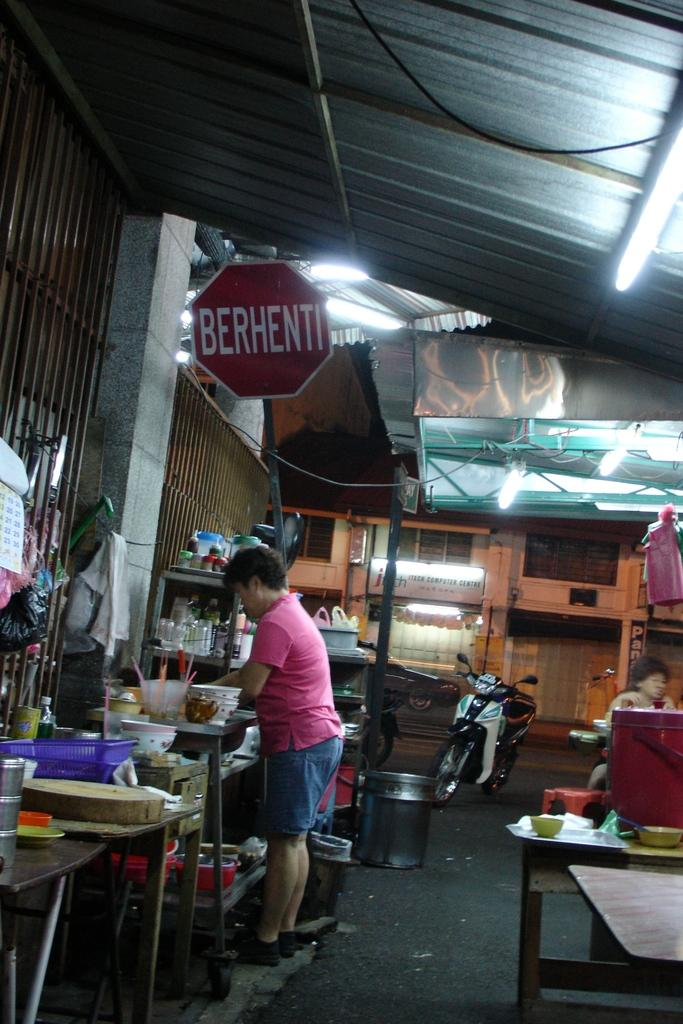What is the main setting of the image? The image depicts a street. Can you describe the person in the image? There is a man standing in the middle of the street. What objects are in the middle of the image? There is a bike in the middle of the image. Are there any other bikes visible in the image? Yes, there is another bike on the right side of the image. What type of zephyr is playing the instrument in the image? There is no zephyr or instrument present in the image. What type of building is visible in the image? The image does not show any buildings; it depicts a street with a man and two bikes. 